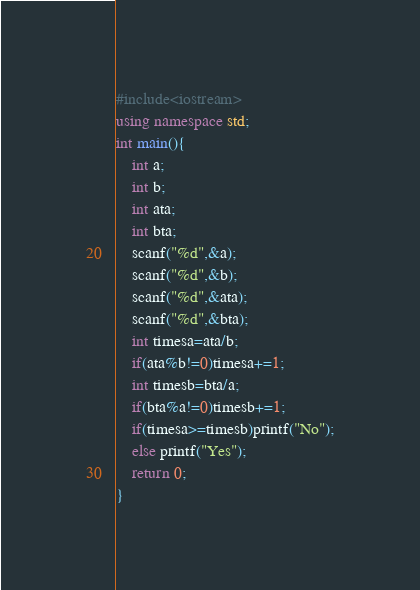Convert code to text. <code><loc_0><loc_0><loc_500><loc_500><_C++_>#include<iostream>
using namespace std;
int main(){
	int a;
	int b;
	int ata;
	int bta;
	scanf("%d",&a);
	scanf("%d",&b);
	scanf("%d",&ata);
	scanf("%d",&bta);
	int timesa=ata/b;
	if(ata%b!=0)timesa+=1;
	int timesb=bta/a;
	if(bta%a!=0)timesb+=1;
	if(timesa>=timesb)printf("No");
	else printf("Yes");
	return 0; 
}</code> 